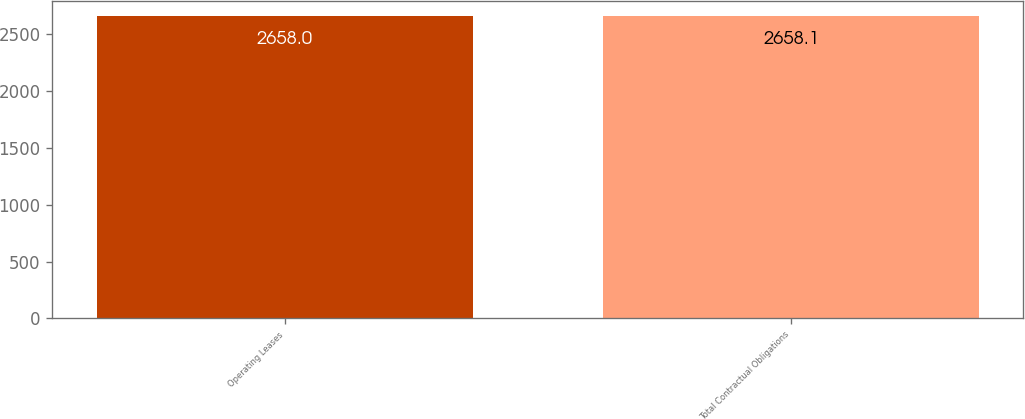Convert chart. <chart><loc_0><loc_0><loc_500><loc_500><bar_chart><fcel>Operating Leases<fcel>Total Contractual Obligations<nl><fcel>2658<fcel>2658.1<nl></chart> 